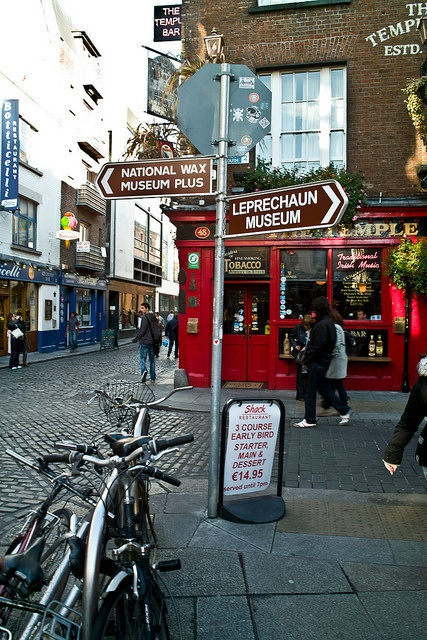Describe the objects in this image and their specific colors. I can see bicycle in white, black, gray, darkgray, and purple tones, bicycle in white, black, gray, purple, and darkgray tones, bicycle in white, black, gray, blue, and lightgray tones, people in white, black, gray, lightgray, and purple tones, and people in white, black, gray, darkgray, and lightgray tones in this image. 